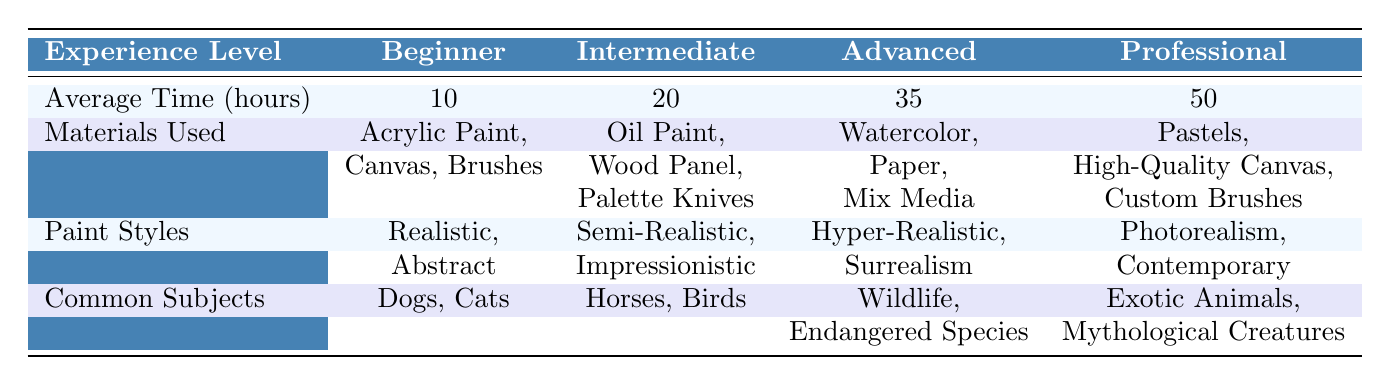What is the average time spent on animal portraits by beginners? According to the table, the row labeled "Average Time (hours)" under the "Beginner" column shows an average time of 10 hours.
Answer: 10 hours Which materials do intermediate artists use? The row labeled "Materials Used" under the "Intermediate" column lists the materials as Oil Paint, Wood Panel, and Palette Knives.
Answer: Oil Paint, Wood Panel, Palette Knives What is the difference in average time spent between advanced and professional artists? The average time for advanced artists is 35 hours, and for professional artists, it is 50 hours. The difference is 50 - 35 = 15 hours.
Answer: 15 hours Do beginners utilize watercolor as a material? The materials listed under "Beginner" do not include watercolor, which means that beginners do not use it.
Answer: No Which artist experience level has the most common subjects related to endangered species? The "Advanced" experience level lists "Wildlife" and "Endangered Species" as common subjects. Therefore, it is the advanced level that has subjects related to endangered species.
Answer: Advanced If the average time spent on animal portraits increases by 5 hours for each experience level, what would be the new average time for professionals? The current average time for professionals is 50 hours. If it increases by 5 hours, the new average would be 50 + 5 = 55 hours.
Answer: 55 hours Which artist experience level uses pastels as a material? The materials under the "Professional" column specifically list pastels as one of their materials.
Answer: Professional What is the highest average time spent, and which experience level corresponds to it? The highest average time is 50 hours, corresponding to the "Professional" experience level.
Answer: 50 hours, Professional What percentage of the total average time spent (10 + 20 + 35 + 50 = 115) is attributed to intermediate artists? The average time for intermediate artists is 20 hours. To find the percentage, we calculate (20/115) * 100 = approximately 17.39%.
Answer: Approximately 17.39% Which paint style is used by advanced artists? The "Paint Styles" row under the "Advanced" column lists "Hyper-Realistic" and "Surrealism." Therefore, these are the styles used by advanced artists.
Answer: Hyper-Realistic, Surrealism 